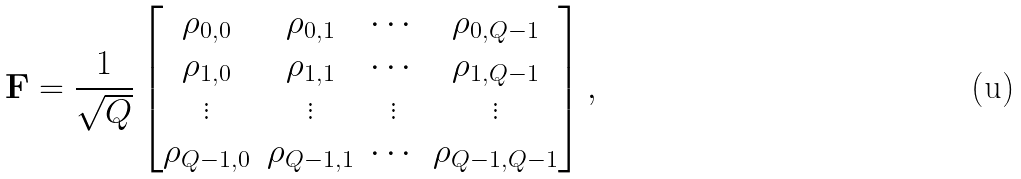Convert formula to latex. <formula><loc_0><loc_0><loc_500><loc_500>{ \mathbf F } = \frac { 1 } { \sqrt { Q } } \begin{bmatrix} \rho _ { 0 , 0 } & \rho _ { 0 , 1 } & \cdots & \rho _ { 0 , Q - 1 } \\ \rho _ { 1 , 0 } & \rho _ { 1 , 1 } & \cdots & \rho _ { 1 , Q - 1 } \\ \vdots & \vdots & \vdots & \vdots \\ \rho _ { Q - 1 , 0 } & \rho _ { Q - 1 , 1 } & \cdots & \rho _ { Q - 1 , Q - 1 } \end{bmatrix} ,</formula> 